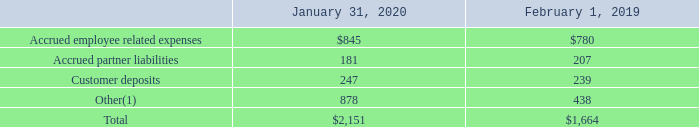O. Accrued Expenses and Other
Accrued expenses and other as of the periods presented consisted of the following (table in millions)
(1) Other primarily consists of litigation accrual, leases accrual, income tax payable and indirect tax accrual.
Accrued partner liabilities primarily relate to rebates and marketing development fund accruals for channel partners, system vendors and systems integrators. Accrued partner liabilities also include accruals for professional service arrangements for which VMware intends to leverage channel partners to directly fulfill the obligation to its customers.
As of January 31, 2020, other included $237 million litigation accrual related to Cirba patent and trademark infringement lawsuit and $155 million accrual for amounts owed to dissenting shareholders in connection with the Pivotal acquisition. Refer to Note E and Note B, respectively, for more information.
Which years does the table provide information for accrued expenses and other? 2020, 2019. What were the accrued partner liabilities in 2019?
Answer scale should be: million. 207. What were the customer deposits in 2020?
Answer scale should be: million. 247. What was the change in Customer deposits between 2019 and 2020?
Answer scale should be: million. 247-239
Answer: 8. How many years did Other exceed $500 million? 2020
Answer: 1. What was the change in the total accrued expenses between 2019 and 2020?
Answer scale should be: percent. (2,151-1,664)/1,664
Answer: 29.27. 